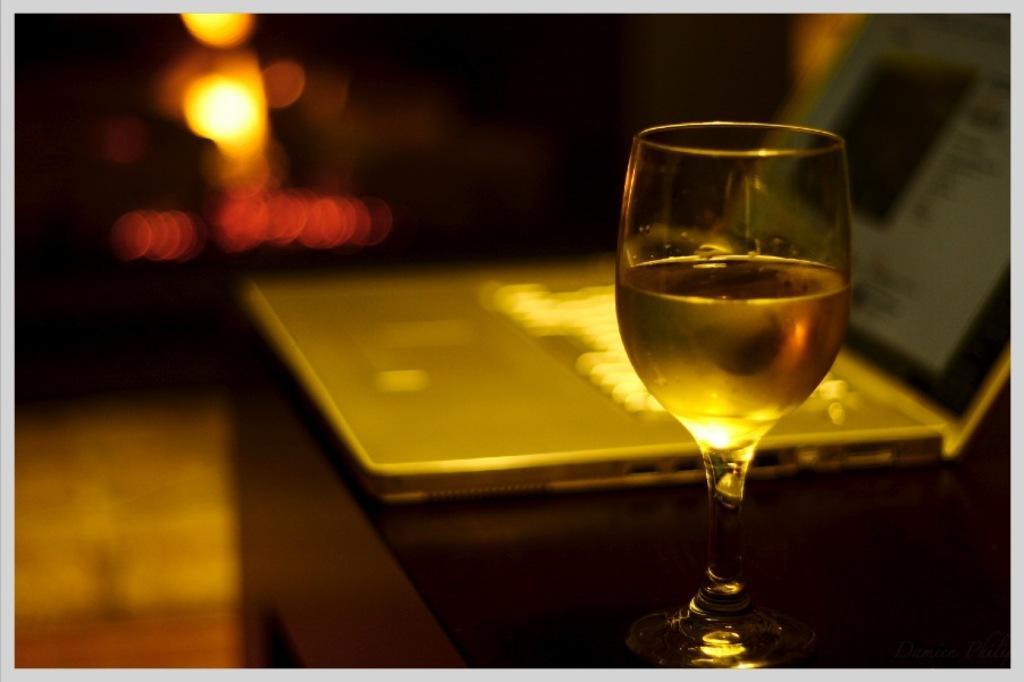How would you summarize this image in a sentence or two? This image consists of a glass of wine. In the background, we can see a laptop kept on the desk. At the bottom, there is a floor. The background is blurred 